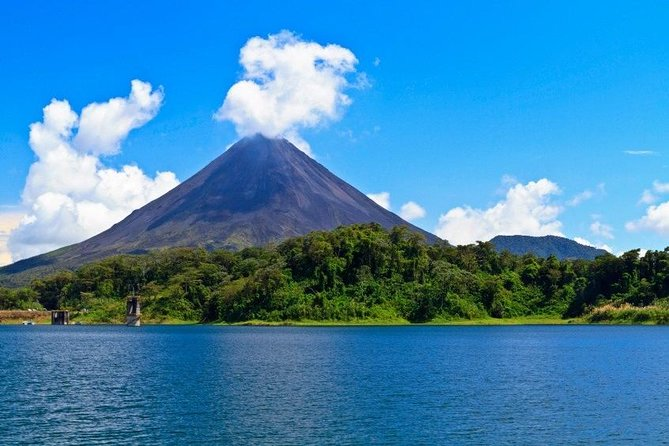Can you tell me about the significance of this location? Certainly! This location is significant for several reasons. The Arenal Volcano is a key part of Costa Rica's natural heritage and is one of the most active volcanoes in Latin America. It has played a major role in shaping the local landscape through past eruptions. Additionally, the area surrounding it, including the Arenal Lake seen in the foreground, is an ecological treasure trove, supporting a myriad of wildlife and plant species. It's also an essential economic resource, attracting thousands of tourists annually who come to marvel at its beauty and explore the rich biodiversity. 